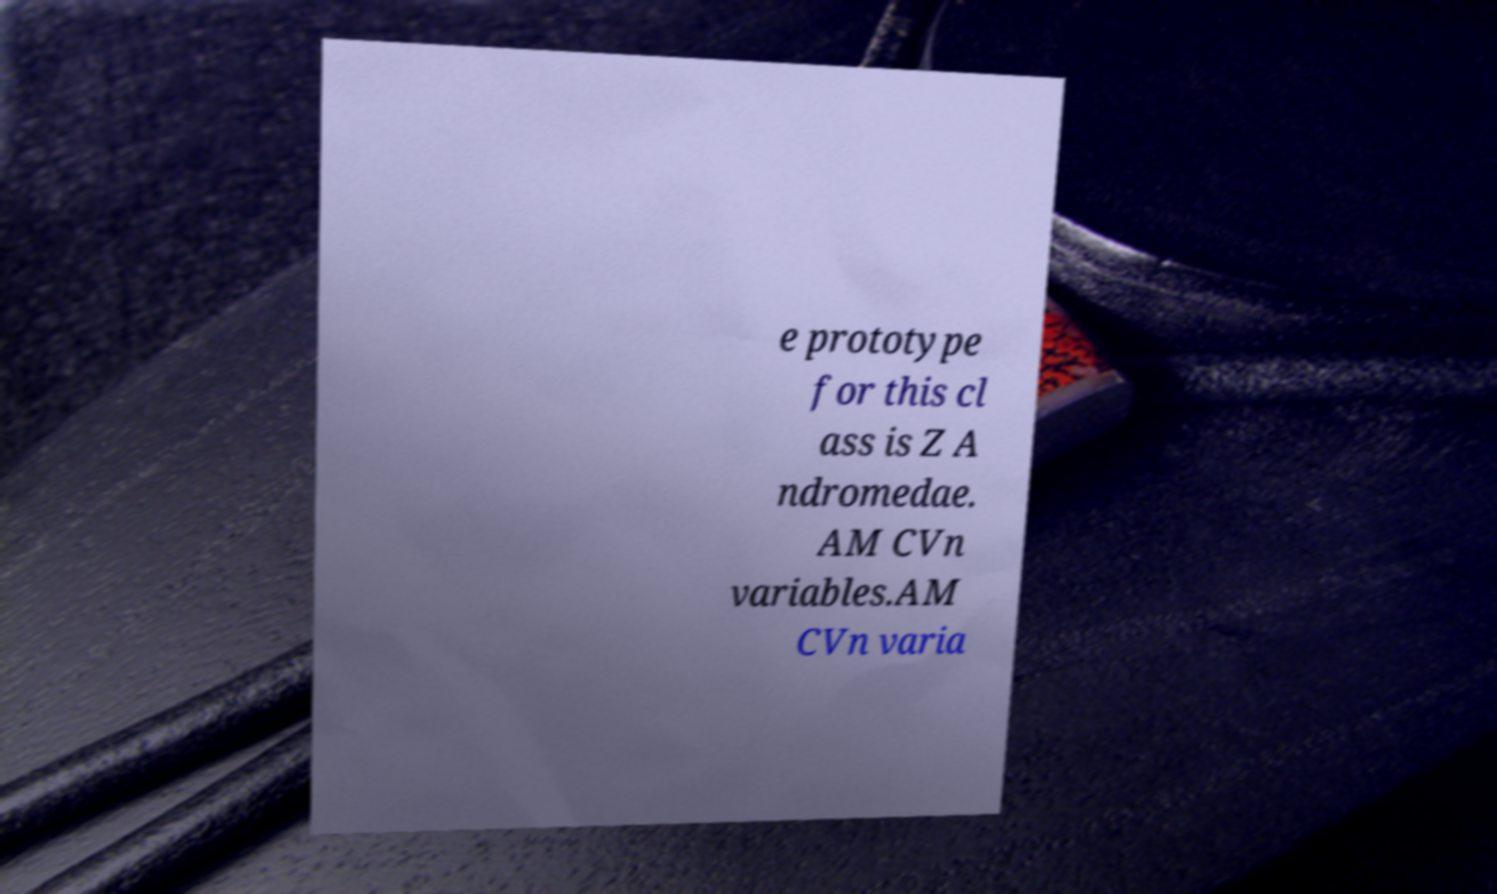Please read and relay the text visible in this image. What does it say? e prototype for this cl ass is Z A ndromedae. AM CVn variables.AM CVn varia 